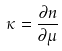Convert formula to latex. <formula><loc_0><loc_0><loc_500><loc_500>\kappa = \frac { \partial n } { \partial \mu }</formula> 